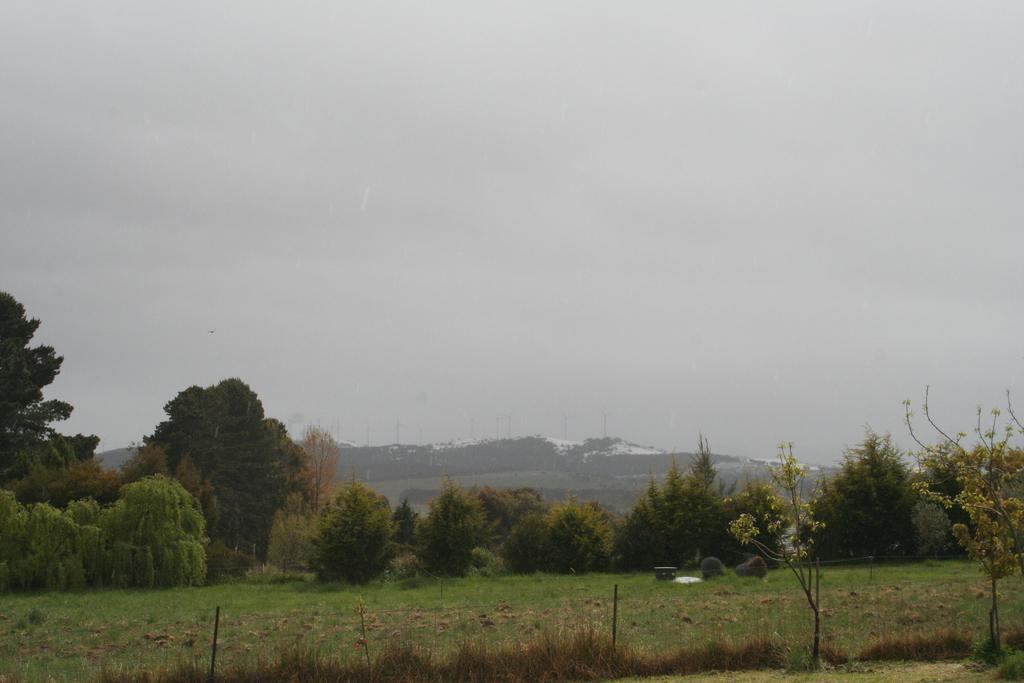Please provide a concise description of this image. In this image I can see few trees and plants in green color. In the background I can see few buildings and the sky is in white color. 